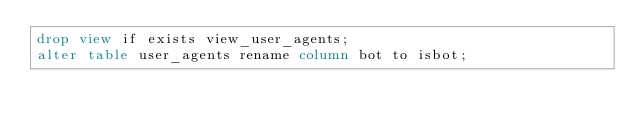Convert code to text. <code><loc_0><loc_0><loc_500><loc_500><_SQL_>drop view if exists view_user_agents;
alter table user_agents rename column bot to isbot;
</code> 